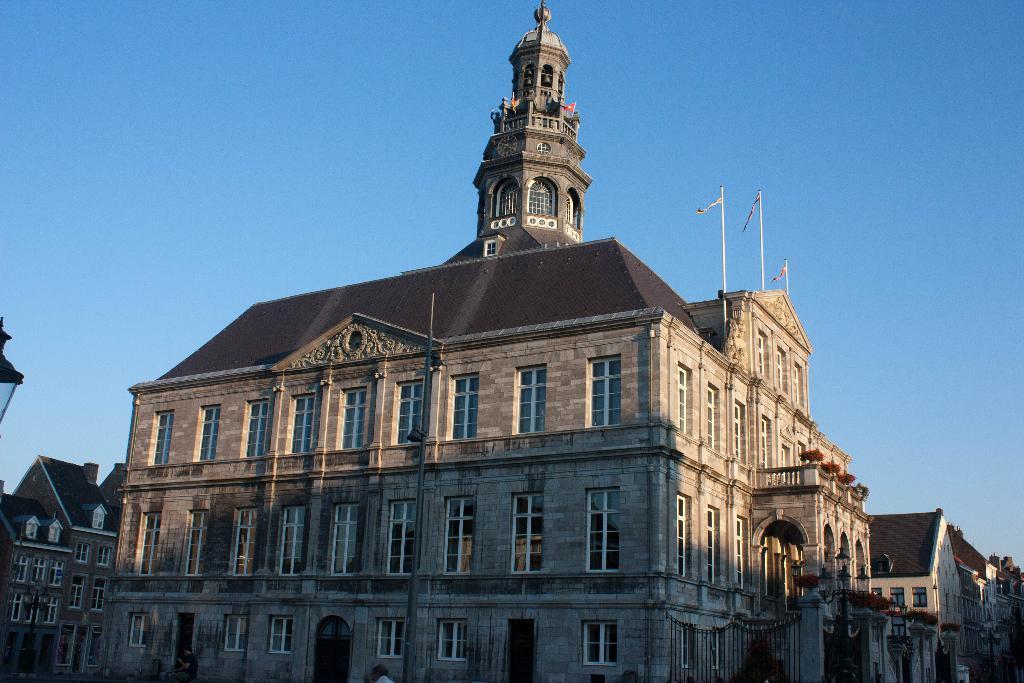How would you summarize this image in a sentence or two? This image consists of buildings, windows, flagpoles, group of people on the road and the sky. This image taken, maybe during a day. 